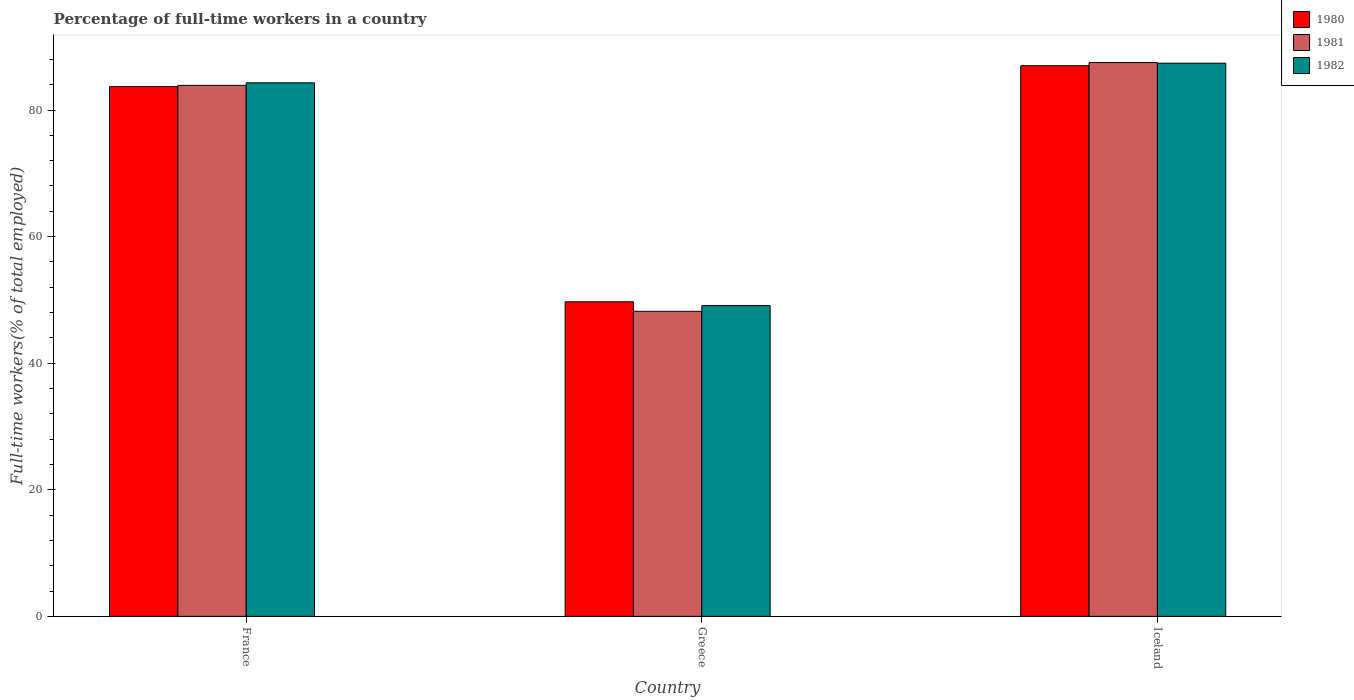How many different coloured bars are there?
Provide a succinct answer. 3. How many groups of bars are there?
Keep it short and to the point. 3. Are the number of bars per tick equal to the number of legend labels?
Keep it short and to the point. Yes. Are the number of bars on each tick of the X-axis equal?
Offer a terse response. Yes. How many bars are there on the 3rd tick from the left?
Give a very brief answer. 3. What is the label of the 3rd group of bars from the left?
Provide a short and direct response. Iceland. What is the percentage of full-time workers in 1980 in Iceland?
Your answer should be compact. 87. Across all countries, what is the maximum percentage of full-time workers in 1982?
Offer a terse response. 87.4. Across all countries, what is the minimum percentage of full-time workers in 1982?
Your answer should be compact. 49.1. What is the total percentage of full-time workers in 1981 in the graph?
Your answer should be very brief. 219.6. What is the difference between the percentage of full-time workers in 1981 in Greece and that in Iceland?
Provide a succinct answer. -39.3. What is the difference between the percentage of full-time workers in 1980 in Greece and the percentage of full-time workers in 1982 in Iceland?
Ensure brevity in your answer.  -37.7. What is the average percentage of full-time workers in 1981 per country?
Ensure brevity in your answer.  73.2. What is the difference between the percentage of full-time workers of/in 1980 and percentage of full-time workers of/in 1981 in Iceland?
Make the answer very short. -0.5. What is the ratio of the percentage of full-time workers in 1982 in France to that in Iceland?
Offer a terse response. 0.96. Is the percentage of full-time workers in 1981 in France less than that in Iceland?
Offer a very short reply. Yes. What is the difference between the highest and the second highest percentage of full-time workers in 1980?
Your response must be concise. -34. What is the difference between the highest and the lowest percentage of full-time workers in 1982?
Make the answer very short. 38.3. In how many countries, is the percentage of full-time workers in 1982 greater than the average percentage of full-time workers in 1982 taken over all countries?
Your answer should be compact. 2. Is the sum of the percentage of full-time workers in 1981 in France and Iceland greater than the maximum percentage of full-time workers in 1980 across all countries?
Your answer should be very brief. Yes. What does the 1st bar from the right in Greece represents?
Your answer should be compact. 1982. Is it the case that in every country, the sum of the percentage of full-time workers in 1981 and percentage of full-time workers in 1982 is greater than the percentage of full-time workers in 1980?
Offer a very short reply. Yes. How many bars are there?
Provide a short and direct response. 9. Are all the bars in the graph horizontal?
Your answer should be compact. No. How many countries are there in the graph?
Your answer should be compact. 3. Are the values on the major ticks of Y-axis written in scientific E-notation?
Offer a very short reply. No. Does the graph contain any zero values?
Ensure brevity in your answer.  No. Does the graph contain grids?
Make the answer very short. No. Where does the legend appear in the graph?
Provide a succinct answer. Top right. How are the legend labels stacked?
Your answer should be compact. Vertical. What is the title of the graph?
Offer a terse response. Percentage of full-time workers in a country. What is the label or title of the X-axis?
Make the answer very short. Country. What is the label or title of the Y-axis?
Offer a very short reply. Full-time workers(% of total employed). What is the Full-time workers(% of total employed) of 1980 in France?
Ensure brevity in your answer.  83.7. What is the Full-time workers(% of total employed) in 1981 in France?
Make the answer very short. 83.9. What is the Full-time workers(% of total employed) in 1982 in France?
Ensure brevity in your answer.  84.3. What is the Full-time workers(% of total employed) in 1980 in Greece?
Your answer should be very brief. 49.7. What is the Full-time workers(% of total employed) of 1981 in Greece?
Provide a short and direct response. 48.2. What is the Full-time workers(% of total employed) of 1982 in Greece?
Make the answer very short. 49.1. What is the Full-time workers(% of total employed) of 1981 in Iceland?
Make the answer very short. 87.5. What is the Full-time workers(% of total employed) of 1982 in Iceland?
Ensure brevity in your answer.  87.4. Across all countries, what is the maximum Full-time workers(% of total employed) in 1981?
Your answer should be very brief. 87.5. Across all countries, what is the maximum Full-time workers(% of total employed) in 1982?
Your response must be concise. 87.4. Across all countries, what is the minimum Full-time workers(% of total employed) in 1980?
Make the answer very short. 49.7. Across all countries, what is the minimum Full-time workers(% of total employed) in 1981?
Keep it short and to the point. 48.2. Across all countries, what is the minimum Full-time workers(% of total employed) in 1982?
Make the answer very short. 49.1. What is the total Full-time workers(% of total employed) in 1980 in the graph?
Offer a very short reply. 220.4. What is the total Full-time workers(% of total employed) in 1981 in the graph?
Give a very brief answer. 219.6. What is the total Full-time workers(% of total employed) in 1982 in the graph?
Ensure brevity in your answer.  220.8. What is the difference between the Full-time workers(% of total employed) in 1981 in France and that in Greece?
Keep it short and to the point. 35.7. What is the difference between the Full-time workers(% of total employed) of 1982 in France and that in Greece?
Your response must be concise. 35.2. What is the difference between the Full-time workers(% of total employed) of 1981 in France and that in Iceland?
Ensure brevity in your answer.  -3.6. What is the difference between the Full-time workers(% of total employed) of 1980 in Greece and that in Iceland?
Provide a short and direct response. -37.3. What is the difference between the Full-time workers(% of total employed) in 1981 in Greece and that in Iceland?
Ensure brevity in your answer.  -39.3. What is the difference between the Full-time workers(% of total employed) of 1982 in Greece and that in Iceland?
Provide a short and direct response. -38.3. What is the difference between the Full-time workers(% of total employed) in 1980 in France and the Full-time workers(% of total employed) in 1981 in Greece?
Give a very brief answer. 35.5. What is the difference between the Full-time workers(% of total employed) in 1980 in France and the Full-time workers(% of total employed) in 1982 in Greece?
Your answer should be compact. 34.6. What is the difference between the Full-time workers(% of total employed) of 1981 in France and the Full-time workers(% of total employed) of 1982 in Greece?
Your answer should be very brief. 34.8. What is the difference between the Full-time workers(% of total employed) of 1980 in France and the Full-time workers(% of total employed) of 1982 in Iceland?
Your response must be concise. -3.7. What is the difference between the Full-time workers(% of total employed) of 1980 in Greece and the Full-time workers(% of total employed) of 1981 in Iceland?
Offer a terse response. -37.8. What is the difference between the Full-time workers(% of total employed) of 1980 in Greece and the Full-time workers(% of total employed) of 1982 in Iceland?
Provide a short and direct response. -37.7. What is the difference between the Full-time workers(% of total employed) of 1981 in Greece and the Full-time workers(% of total employed) of 1982 in Iceland?
Offer a terse response. -39.2. What is the average Full-time workers(% of total employed) of 1980 per country?
Offer a terse response. 73.47. What is the average Full-time workers(% of total employed) in 1981 per country?
Your answer should be very brief. 73.2. What is the average Full-time workers(% of total employed) in 1982 per country?
Provide a succinct answer. 73.6. What is the difference between the Full-time workers(% of total employed) of 1980 and Full-time workers(% of total employed) of 1981 in France?
Keep it short and to the point. -0.2. What is the difference between the Full-time workers(% of total employed) of 1980 and Full-time workers(% of total employed) of 1981 in Greece?
Offer a very short reply. 1.5. What is the difference between the Full-time workers(% of total employed) of 1980 and Full-time workers(% of total employed) of 1981 in Iceland?
Give a very brief answer. -0.5. What is the difference between the Full-time workers(% of total employed) of 1981 and Full-time workers(% of total employed) of 1982 in Iceland?
Offer a very short reply. 0.1. What is the ratio of the Full-time workers(% of total employed) of 1980 in France to that in Greece?
Your answer should be compact. 1.68. What is the ratio of the Full-time workers(% of total employed) in 1981 in France to that in Greece?
Offer a terse response. 1.74. What is the ratio of the Full-time workers(% of total employed) of 1982 in France to that in Greece?
Provide a succinct answer. 1.72. What is the ratio of the Full-time workers(% of total employed) of 1980 in France to that in Iceland?
Your response must be concise. 0.96. What is the ratio of the Full-time workers(% of total employed) in 1981 in France to that in Iceland?
Provide a succinct answer. 0.96. What is the ratio of the Full-time workers(% of total employed) in 1982 in France to that in Iceland?
Provide a succinct answer. 0.96. What is the ratio of the Full-time workers(% of total employed) in 1980 in Greece to that in Iceland?
Make the answer very short. 0.57. What is the ratio of the Full-time workers(% of total employed) in 1981 in Greece to that in Iceland?
Offer a very short reply. 0.55. What is the ratio of the Full-time workers(% of total employed) of 1982 in Greece to that in Iceland?
Offer a terse response. 0.56. What is the difference between the highest and the lowest Full-time workers(% of total employed) of 1980?
Your response must be concise. 37.3. What is the difference between the highest and the lowest Full-time workers(% of total employed) of 1981?
Offer a very short reply. 39.3. What is the difference between the highest and the lowest Full-time workers(% of total employed) in 1982?
Provide a succinct answer. 38.3. 